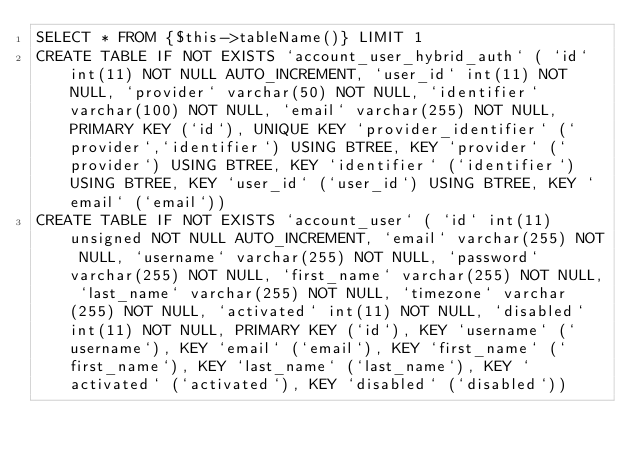Convert code to text. <code><loc_0><loc_0><loc_500><loc_500><_SQL_>SELECT * FROM {$this->tableName()} LIMIT 1
CREATE TABLE IF NOT EXISTS `account_user_hybrid_auth` ( `id` int(11) NOT NULL AUTO_INCREMENT, `user_id` int(11) NOT NULL, `provider` varchar(50) NOT NULL, `identifier` varchar(100) NOT NULL, `email` varchar(255) NOT NULL, PRIMARY KEY (`id`), UNIQUE KEY `provider_identifier` (`provider`,`identifier`) USING BTREE, KEY `provider` (`provider`) USING BTREE, KEY `identifier` (`identifier`) USING BTREE, KEY `user_id` (`user_id`) USING BTREE, KEY `email` (`email`))
CREATE TABLE IF NOT EXISTS `account_user` ( `id` int(11) unsigned NOT NULL AUTO_INCREMENT, `email` varchar(255) NOT NULL, `username` varchar(255) NOT NULL, `password` varchar(255) NOT NULL, `first_name` varchar(255) NOT NULL, `last_name` varchar(255) NOT NULL, `timezone` varchar(255) NOT NULL, `activated` int(11) NOT NULL, `disabled` int(11) NOT NULL, PRIMARY KEY (`id`), KEY `username` (`username`), KEY `email` (`email`), KEY `first_name` (`first_name`), KEY `last_name` (`last_name`), KEY `activated` (`activated`), KEY `disabled` (`disabled`))
</code> 